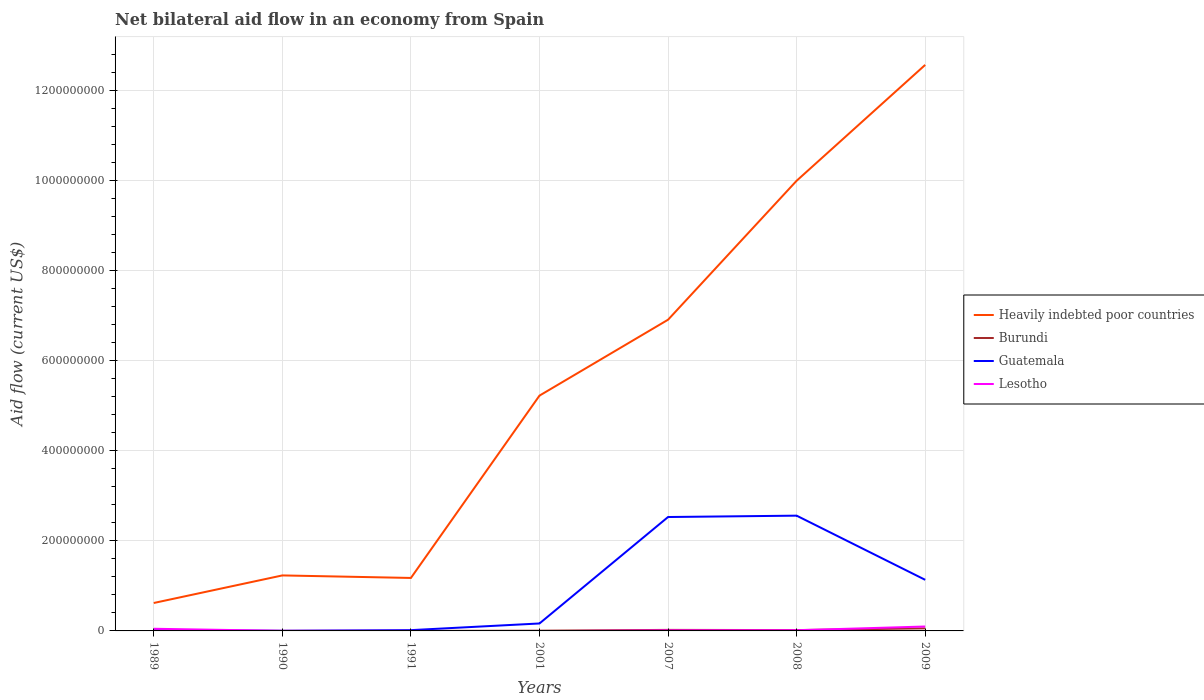Is the number of lines equal to the number of legend labels?
Offer a very short reply. No. Across all years, what is the maximum net bilateral aid flow in Guatemala?
Your response must be concise. 2.50e+05. What is the total net bilateral aid flow in Guatemala in the graph?
Offer a terse response. -1.50e+06. What is the difference between the highest and the second highest net bilateral aid flow in Lesotho?
Give a very brief answer. 9.77e+06. What is the difference between the highest and the lowest net bilateral aid flow in Lesotho?
Your answer should be compact. 2. How many years are there in the graph?
Your response must be concise. 7. Where does the legend appear in the graph?
Make the answer very short. Center right. What is the title of the graph?
Your response must be concise. Net bilateral aid flow in an economy from Spain. Does "Paraguay" appear as one of the legend labels in the graph?
Make the answer very short. No. What is the label or title of the Y-axis?
Make the answer very short. Aid flow (current US$). What is the Aid flow (current US$) in Heavily indebted poor countries in 1989?
Keep it short and to the point. 6.20e+07. What is the Aid flow (current US$) in Burundi in 1989?
Your response must be concise. 4.00e+04. What is the Aid flow (current US$) in Guatemala in 1989?
Ensure brevity in your answer.  1.59e+06. What is the Aid flow (current US$) of Lesotho in 1989?
Your answer should be compact. 4.79e+06. What is the Aid flow (current US$) in Heavily indebted poor countries in 1990?
Ensure brevity in your answer.  1.23e+08. What is the Aid flow (current US$) in Lesotho in 1990?
Ensure brevity in your answer.  1.50e+05. What is the Aid flow (current US$) of Heavily indebted poor countries in 1991?
Make the answer very short. 1.18e+08. What is the Aid flow (current US$) in Burundi in 1991?
Make the answer very short. 9.00e+04. What is the Aid flow (current US$) of Guatemala in 1991?
Provide a short and direct response. 1.75e+06. What is the Aid flow (current US$) of Lesotho in 1991?
Offer a very short reply. 5.00e+04. What is the Aid flow (current US$) in Heavily indebted poor countries in 2001?
Your answer should be very brief. 5.22e+08. What is the Aid flow (current US$) in Burundi in 2001?
Provide a short and direct response. 5.10e+05. What is the Aid flow (current US$) in Guatemala in 2001?
Offer a terse response. 1.65e+07. What is the Aid flow (current US$) of Heavily indebted poor countries in 2007?
Give a very brief answer. 6.91e+08. What is the Aid flow (current US$) of Burundi in 2007?
Your answer should be very brief. 2.29e+06. What is the Aid flow (current US$) in Guatemala in 2007?
Give a very brief answer. 2.53e+08. What is the Aid flow (current US$) in Lesotho in 2007?
Your answer should be compact. 1.18e+06. What is the Aid flow (current US$) in Heavily indebted poor countries in 2008?
Provide a short and direct response. 9.99e+08. What is the Aid flow (current US$) in Burundi in 2008?
Offer a terse response. 1.88e+06. What is the Aid flow (current US$) of Guatemala in 2008?
Offer a very short reply. 2.56e+08. What is the Aid flow (current US$) in Lesotho in 2008?
Keep it short and to the point. 1.53e+06. What is the Aid flow (current US$) of Heavily indebted poor countries in 2009?
Provide a succinct answer. 1.26e+09. What is the Aid flow (current US$) in Burundi in 2009?
Offer a terse response. 5.70e+06. What is the Aid flow (current US$) in Guatemala in 2009?
Make the answer very short. 1.13e+08. What is the Aid flow (current US$) in Lesotho in 2009?
Provide a succinct answer. 9.77e+06. Across all years, what is the maximum Aid flow (current US$) of Heavily indebted poor countries?
Your answer should be very brief. 1.26e+09. Across all years, what is the maximum Aid flow (current US$) of Burundi?
Ensure brevity in your answer.  5.70e+06. Across all years, what is the maximum Aid flow (current US$) of Guatemala?
Offer a terse response. 2.56e+08. Across all years, what is the maximum Aid flow (current US$) in Lesotho?
Make the answer very short. 9.77e+06. Across all years, what is the minimum Aid flow (current US$) in Heavily indebted poor countries?
Make the answer very short. 6.20e+07. Across all years, what is the minimum Aid flow (current US$) of Guatemala?
Make the answer very short. 2.50e+05. Across all years, what is the minimum Aid flow (current US$) of Lesotho?
Your answer should be compact. 0. What is the total Aid flow (current US$) of Heavily indebted poor countries in the graph?
Keep it short and to the point. 3.77e+09. What is the total Aid flow (current US$) of Burundi in the graph?
Provide a succinct answer. 1.06e+07. What is the total Aid flow (current US$) in Guatemala in the graph?
Ensure brevity in your answer.  6.42e+08. What is the total Aid flow (current US$) of Lesotho in the graph?
Make the answer very short. 1.75e+07. What is the difference between the Aid flow (current US$) of Heavily indebted poor countries in 1989 and that in 1990?
Ensure brevity in your answer.  -6.12e+07. What is the difference between the Aid flow (current US$) in Burundi in 1989 and that in 1990?
Make the answer very short. -5.00e+04. What is the difference between the Aid flow (current US$) in Guatemala in 1989 and that in 1990?
Offer a very short reply. 1.34e+06. What is the difference between the Aid flow (current US$) in Lesotho in 1989 and that in 1990?
Your answer should be compact. 4.64e+06. What is the difference between the Aid flow (current US$) in Heavily indebted poor countries in 1989 and that in 1991?
Your answer should be compact. -5.56e+07. What is the difference between the Aid flow (current US$) in Burundi in 1989 and that in 1991?
Provide a succinct answer. -5.00e+04. What is the difference between the Aid flow (current US$) of Guatemala in 1989 and that in 1991?
Provide a short and direct response. -1.60e+05. What is the difference between the Aid flow (current US$) in Lesotho in 1989 and that in 1991?
Offer a terse response. 4.74e+06. What is the difference between the Aid flow (current US$) of Heavily indebted poor countries in 1989 and that in 2001?
Ensure brevity in your answer.  -4.60e+08. What is the difference between the Aid flow (current US$) in Burundi in 1989 and that in 2001?
Offer a very short reply. -4.70e+05. What is the difference between the Aid flow (current US$) in Guatemala in 1989 and that in 2001?
Provide a short and direct response. -1.49e+07. What is the difference between the Aid flow (current US$) in Heavily indebted poor countries in 1989 and that in 2007?
Ensure brevity in your answer.  -6.29e+08. What is the difference between the Aid flow (current US$) of Burundi in 1989 and that in 2007?
Provide a succinct answer. -2.25e+06. What is the difference between the Aid flow (current US$) of Guatemala in 1989 and that in 2007?
Provide a succinct answer. -2.51e+08. What is the difference between the Aid flow (current US$) of Lesotho in 1989 and that in 2007?
Keep it short and to the point. 3.61e+06. What is the difference between the Aid flow (current US$) in Heavily indebted poor countries in 1989 and that in 2008?
Ensure brevity in your answer.  -9.37e+08. What is the difference between the Aid flow (current US$) in Burundi in 1989 and that in 2008?
Ensure brevity in your answer.  -1.84e+06. What is the difference between the Aid flow (current US$) of Guatemala in 1989 and that in 2008?
Ensure brevity in your answer.  -2.54e+08. What is the difference between the Aid flow (current US$) in Lesotho in 1989 and that in 2008?
Your response must be concise. 3.26e+06. What is the difference between the Aid flow (current US$) of Heavily indebted poor countries in 1989 and that in 2009?
Your answer should be very brief. -1.19e+09. What is the difference between the Aid flow (current US$) of Burundi in 1989 and that in 2009?
Give a very brief answer. -5.66e+06. What is the difference between the Aid flow (current US$) in Guatemala in 1989 and that in 2009?
Ensure brevity in your answer.  -1.12e+08. What is the difference between the Aid flow (current US$) of Lesotho in 1989 and that in 2009?
Provide a short and direct response. -4.98e+06. What is the difference between the Aid flow (current US$) of Heavily indebted poor countries in 1990 and that in 1991?
Offer a terse response. 5.61e+06. What is the difference between the Aid flow (current US$) in Burundi in 1990 and that in 1991?
Give a very brief answer. 0. What is the difference between the Aid flow (current US$) of Guatemala in 1990 and that in 1991?
Make the answer very short. -1.50e+06. What is the difference between the Aid flow (current US$) in Heavily indebted poor countries in 1990 and that in 2001?
Make the answer very short. -3.99e+08. What is the difference between the Aid flow (current US$) in Burundi in 1990 and that in 2001?
Give a very brief answer. -4.20e+05. What is the difference between the Aid flow (current US$) of Guatemala in 1990 and that in 2001?
Offer a terse response. -1.63e+07. What is the difference between the Aid flow (current US$) in Heavily indebted poor countries in 1990 and that in 2007?
Provide a succinct answer. -5.68e+08. What is the difference between the Aid flow (current US$) of Burundi in 1990 and that in 2007?
Give a very brief answer. -2.20e+06. What is the difference between the Aid flow (current US$) in Guatemala in 1990 and that in 2007?
Offer a terse response. -2.53e+08. What is the difference between the Aid flow (current US$) in Lesotho in 1990 and that in 2007?
Provide a short and direct response. -1.03e+06. What is the difference between the Aid flow (current US$) in Heavily indebted poor countries in 1990 and that in 2008?
Make the answer very short. -8.76e+08. What is the difference between the Aid flow (current US$) of Burundi in 1990 and that in 2008?
Keep it short and to the point. -1.79e+06. What is the difference between the Aid flow (current US$) of Guatemala in 1990 and that in 2008?
Offer a very short reply. -2.56e+08. What is the difference between the Aid flow (current US$) in Lesotho in 1990 and that in 2008?
Your answer should be compact. -1.38e+06. What is the difference between the Aid flow (current US$) of Heavily indebted poor countries in 1990 and that in 2009?
Provide a succinct answer. -1.13e+09. What is the difference between the Aid flow (current US$) in Burundi in 1990 and that in 2009?
Make the answer very short. -5.61e+06. What is the difference between the Aid flow (current US$) of Guatemala in 1990 and that in 2009?
Make the answer very short. -1.13e+08. What is the difference between the Aid flow (current US$) of Lesotho in 1990 and that in 2009?
Offer a terse response. -9.62e+06. What is the difference between the Aid flow (current US$) of Heavily indebted poor countries in 1991 and that in 2001?
Provide a succinct answer. -4.05e+08. What is the difference between the Aid flow (current US$) in Burundi in 1991 and that in 2001?
Make the answer very short. -4.20e+05. What is the difference between the Aid flow (current US$) in Guatemala in 1991 and that in 2001?
Give a very brief answer. -1.48e+07. What is the difference between the Aid flow (current US$) of Heavily indebted poor countries in 1991 and that in 2007?
Your answer should be very brief. -5.73e+08. What is the difference between the Aid flow (current US$) of Burundi in 1991 and that in 2007?
Ensure brevity in your answer.  -2.20e+06. What is the difference between the Aid flow (current US$) of Guatemala in 1991 and that in 2007?
Your response must be concise. -2.51e+08. What is the difference between the Aid flow (current US$) of Lesotho in 1991 and that in 2007?
Offer a very short reply. -1.13e+06. What is the difference between the Aid flow (current US$) of Heavily indebted poor countries in 1991 and that in 2008?
Ensure brevity in your answer.  -8.82e+08. What is the difference between the Aid flow (current US$) of Burundi in 1991 and that in 2008?
Your response must be concise. -1.79e+06. What is the difference between the Aid flow (current US$) of Guatemala in 1991 and that in 2008?
Keep it short and to the point. -2.54e+08. What is the difference between the Aid flow (current US$) in Lesotho in 1991 and that in 2008?
Give a very brief answer. -1.48e+06. What is the difference between the Aid flow (current US$) in Heavily indebted poor countries in 1991 and that in 2009?
Your response must be concise. -1.14e+09. What is the difference between the Aid flow (current US$) of Burundi in 1991 and that in 2009?
Give a very brief answer. -5.61e+06. What is the difference between the Aid flow (current US$) in Guatemala in 1991 and that in 2009?
Keep it short and to the point. -1.12e+08. What is the difference between the Aid flow (current US$) of Lesotho in 1991 and that in 2009?
Offer a terse response. -9.72e+06. What is the difference between the Aid flow (current US$) in Heavily indebted poor countries in 2001 and that in 2007?
Give a very brief answer. -1.69e+08. What is the difference between the Aid flow (current US$) of Burundi in 2001 and that in 2007?
Provide a succinct answer. -1.78e+06. What is the difference between the Aid flow (current US$) in Guatemala in 2001 and that in 2007?
Provide a succinct answer. -2.36e+08. What is the difference between the Aid flow (current US$) of Heavily indebted poor countries in 2001 and that in 2008?
Your answer should be very brief. -4.77e+08. What is the difference between the Aid flow (current US$) in Burundi in 2001 and that in 2008?
Give a very brief answer. -1.37e+06. What is the difference between the Aid flow (current US$) of Guatemala in 2001 and that in 2008?
Ensure brevity in your answer.  -2.39e+08. What is the difference between the Aid flow (current US$) in Heavily indebted poor countries in 2001 and that in 2009?
Your answer should be very brief. -7.34e+08. What is the difference between the Aid flow (current US$) of Burundi in 2001 and that in 2009?
Your response must be concise. -5.19e+06. What is the difference between the Aid flow (current US$) of Guatemala in 2001 and that in 2009?
Provide a succinct answer. -9.69e+07. What is the difference between the Aid flow (current US$) of Heavily indebted poor countries in 2007 and that in 2008?
Provide a short and direct response. -3.09e+08. What is the difference between the Aid flow (current US$) of Guatemala in 2007 and that in 2008?
Provide a succinct answer. -3.02e+06. What is the difference between the Aid flow (current US$) of Lesotho in 2007 and that in 2008?
Your answer should be compact. -3.50e+05. What is the difference between the Aid flow (current US$) in Heavily indebted poor countries in 2007 and that in 2009?
Offer a terse response. -5.66e+08. What is the difference between the Aid flow (current US$) of Burundi in 2007 and that in 2009?
Offer a very short reply. -3.41e+06. What is the difference between the Aid flow (current US$) in Guatemala in 2007 and that in 2009?
Offer a terse response. 1.39e+08. What is the difference between the Aid flow (current US$) of Lesotho in 2007 and that in 2009?
Keep it short and to the point. -8.59e+06. What is the difference between the Aid flow (current US$) of Heavily indebted poor countries in 2008 and that in 2009?
Offer a very short reply. -2.57e+08. What is the difference between the Aid flow (current US$) of Burundi in 2008 and that in 2009?
Provide a succinct answer. -3.82e+06. What is the difference between the Aid flow (current US$) of Guatemala in 2008 and that in 2009?
Offer a very short reply. 1.42e+08. What is the difference between the Aid flow (current US$) in Lesotho in 2008 and that in 2009?
Provide a short and direct response. -8.24e+06. What is the difference between the Aid flow (current US$) in Heavily indebted poor countries in 1989 and the Aid flow (current US$) in Burundi in 1990?
Offer a terse response. 6.19e+07. What is the difference between the Aid flow (current US$) in Heavily indebted poor countries in 1989 and the Aid flow (current US$) in Guatemala in 1990?
Your answer should be compact. 6.18e+07. What is the difference between the Aid flow (current US$) in Heavily indebted poor countries in 1989 and the Aid flow (current US$) in Lesotho in 1990?
Give a very brief answer. 6.18e+07. What is the difference between the Aid flow (current US$) in Burundi in 1989 and the Aid flow (current US$) in Lesotho in 1990?
Ensure brevity in your answer.  -1.10e+05. What is the difference between the Aid flow (current US$) of Guatemala in 1989 and the Aid flow (current US$) of Lesotho in 1990?
Offer a terse response. 1.44e+06. What is the difference between the Aid flow (current US$) of Heavily indebted poor countries in 1989 and the Aid flow (current US$) of Burundi in 1991?
Your answer should be very brief. 6.19e+07. What is the difference between the Aid flow (current US$) of Heavily indebted poor countries in 1989 and the Aid flow (current US$) of Guatemala in 1991?
Your answer should be compact. 6.02e+07. What is the difference between the Aid flow (current US$) of Heavily indebted poor countries in 1989 and the Aid flow (current US$) of Lesotho in 1991?
Your answer should be compact. 6.20e+07. What is the difference between the Aid flow (current US$) of Burundi in 1989 and the Aid flow (current US$) of Guatemala in 1991?
Give a very brief answer. -1.71e+06. What is the difference between the Aid flow (current US$) of Guatemala in 1989 and the Aid flow (current US$) of Lesotho in 1991?
Ensure brevity in your answer.  1.54e+06. What is the difference between the Aid flow (current US$) in Heavily indebted poor countries in 1989 and the Aid flow (current US$) in Burundi in 2001?
Keep it short and to the point. 6.15e+07. What is the difference between the Aid flow (current US$) of Heavily indebted poor countries in 1989 and the Aid flow (current US$) of Guatemala in 2001?
Give a very brief answer. 4.55e+07. What is the difference between the Aid flow (current US$) of Burundi in 1989 and the Aid flow (current US$) of Guatemala in 2001?
Offer a terse response. -1.65e+07. What is the difference between the Aid flow (current US$) in Heavily indebted poor countries in 1989 and the Aid flow (current US$) in Burundi in 2007?
Ensure brevity in your answer.  5.97e+07. What is the difference between the Aid flow (current US$) in Heavily indebted poor countries in 1989 and the Aid flow (current US$) in Guatemala in 2007?
Give a very brief answer. -1.91e+08. What is the difference between the Aid flow (current US$) in Heavily indebted poor countries in 1989 and the Aid flow (current US$) in Lesotho in 2007?
Make the answer very short. 6.08e+07. What is the difference between the Aid flow (current US$) of Burundi in 1989 and the Aid flow (current US$) of Guatemala in 2007?
Provide a succinct answer. -2.53e+08. What is the difference between the Aid flow (current US$) in Burundi in 1989 and the Aid flow (current US$) in Lesotho in 2007?
Give a very brief answer. -1.14e+06. What is the difference between the Aid flow (current US$) of Guatemala in 1989 and the Aid flow (current US$) of Lesotho in 2007?
Your answer should be compact. 4.10e+05. What is the difference between the Aid flow (current US$) of Heavily indebted poor countries in 1989 and the Aid flow (current US$) of Burundi in 2008?
Make the answer very short. 6.01e+07. What is the difference between the Aid flow (current US$) in Heavily indebted poor countries in 1989 and the Aid flow (current US$) in Guatemala in 2008?
Give a very brief answer. -1.94e+08. What is the difference between the Aid flow (current US$) in Heavily indebted poor countries in 1989 and the Aid flow (current US$) in Lesotho in 2008?
Offer a very short reply. 6.05e+07. What is the difference between the Aid flow (current US$) of Burundi in 1989 and the Aid flow (current US$) of Guatemala in 2008?
Your answer should be compact. -2.56e+08. What is the difference between the Aid flow (current US$) in Burundi in 1989 and the Aid flow (current US$) in Lesotho in 2008?
Offer a terse response. -1.49e+06. What is the difference between the Aid flow (current US$) of Guatemala in 1989 and the Aid flow (current US$) of Lesotho in 2008?
Ensure brevity in your answer.  6.00e+04. What is the difference between the Aid flow (current US$) of Heavily indebted poor countries in 1989 and the Aid flow (current US$) of Burundi in 2009?
Your response must be concise. 5.63e+07. What is the difference between the Aid flow (current US$) in Heavily indebted poor countries in 1989 and the Aid flow (current US$) in Guatemala in 2009?
Your response must be concise. -5.14e+07. What is the difference between the Aid flow (current US$) in Heavily indebted poor countries in 1989 and the Aid flow (current US$) in Lesotho in 2009?
Make the answer very short. 5.22e+07. What is the difference between the Aid flow (current US$) in Burundi in 1989 and the Aid flow (current US$) in Guatemala in 2009?
Keep it short and to the point. -1.13e+08. What is the difference between the Aid flow (current US$) of Burundi in 1989 and the Aid flow (current US$) of Lesotho in 2009?
Your response must be concise. -9.73e+06. What is the difference between the Aid flow (current US$) in Guatemala in 1989 and the Aid flow (current US$) in Lesotho in 2009?
Provide a short and direct response. -8.18e+06. What is the difference between the Aid flow (current US$) in Heavily indebted poor countries in 1990 and the Aid flow (current US$) in Burundi in 1991?
Offer a very short reply. 1.23e+08. What is the difference between the Aid flow (current US$) of Heavily indebted poor countries in 1990 and the Aid flow (current US$) of Guatemala in 1991?
Keep it short and to the point. 1.21e+08. What is the difference between the Aid flow (current US$) of Heavily indebted poor countries in 1990 and the Aid flow (current US$) of Lesotho in 1991?
Keep it short and to the point. 1.23e+08. What is the difference between the Aid flow (current US$) in Burundi in 1990 and the Aid flow (current US$) in Guatemala in 1991?
Offer a very short reply. -1.66e+06. What is the difference between the Aid flow (current US$) in Burundi in 1990 and the Aid flow (current US$) in Lesotho in 1991?
Ensure brevity in your answer.  4.00e+04. What is the difference between the Aid flow (current US$) of Heavily indebted poor countries in 1990 and the Aid flow (current US$) of Burundi in 2001?
Provide a short and direct response. 1.23e+08. What is the difference between the Aid flow (current US$) in Heavily indebted poor countries in 1990 and the Aid flow (current US$) in Guatemala in 2001?
Provide a succinct answer. 1.07e+08. What is the difference between the Aid flow (current US$) in Burundi in 1990 and the Aid flow (current US$) in Guatemala in 2001?
Your response must be concise. -1.64e+07. What is the difference between the Aid flow (current US$) of Heavily indebted poor countries in 1990 and the Aid flow (current US$) of Burundi in 2007?
Give a very brief answer. 1.21e+08. What is the difference between the Aid flow (current US$) of Heavily indebted poor countries in 1990 and the Aid flow (current US$) of Guatemala in 2007?
Provide a short and direct response. -1.30e+08. What is the difference between the Aid flow (current US$) of Heavily indebted poor countries in 1990 and the Aid flow (current US$) of Lesotho in 2007?
Provide a short and direct response. 1.22e+08. What is the difference between the Aid flow (current US$) in Burundi in 1990 and the Aid flow (current US$) in Guatemala in 2007?
Offer a terse response. -2.53e+08. What is the difference between the Aid flow (current US$) in Burundi in 1990 and the Aid flow (current US$) in Lesotho in 2007?
Give a very brief answer. -1.09e+06. What is the difference between the Aid flow (current US$) in Guatemala in 1990 and the Aid flow (current US$) in Lesotho in 2007?
Your answer should be compact. -9.30e+05. What is the difference between the Aid flow (current US$) of Heavily indebted poor countries in 1990 and the Aid flow (current US$) of Burundi in 2008?
Give a very brief answer. 1.21e+08. What is the difference between the Aid flow (current US$) of Heavily indebted poor countries in 1990 and the Aid flow (current US$) of Guatemala in 2008?
Offer a very short reply. -1.33e+08. What is the difference between the Aid flow (current US$) of Heavily indebted poor countries in 1990 and the Aid flow (current US$) of Lesotho in 2008?
Keep it short and to the point. 1.22e+08. What is the difference between the Aid flow (current US$) in Burundi in 1990 and the Aid flow (current US$) in Guatemala in 2008?
Provide a short and direct response. -2.56e+08. What is the difference between the Aid flow (current US$) in Burundi in 1990 and the Aid flow (current US$) in Lesotho in 2008?
Your answer should be very brief. -1.44e+06. What is the difference between the Aid flow (current US$) of Guatemala in 1990 and the Aid flow (current US$) of Lesotho in 2008?
Offer a terse response. -1.28e+06. What is the difference between the Aid flow (current US$) in Heavily indebted poor countries in 1990 and the Aid flow (current US$) in Burundi in 2009?
Provide a succinct answer. 1.17e+08. What is the difference between the Aid flow (current US$) of Heavily indebted poor countries in 1990 and the Aid flow (current US$) of Guatemala in 2009?
Give a very brief answer. 9.76e+06. What is the difference between the Aid flow (current US$) of Heavily indebted poor countries in 1990 and the Aid flow (current US$) of Lesotho in 2009?
Provide a succinct answer. 1.13e+08. What is the difference between the Aid flow (current US$) of Burundi in 1990 and the Aid flow (current US$) of Guatemala in 2009?
Your response must be concise. -1.13e+08. What is the difference between the Aid flow (current US$) of Burundi in 1990 and the Aid flow (current US$) of Lesotho in 2009?
Provide a short and direct response. -9.68e+06. What is the difference between the Aid flow (current US$) in Guatemala in 1990 and the Aid flow (current US$) in Lesotho in 2009?
Offer a very short reply. -9.52e+06. What is the difference between the Aid flow (current US$) of Heavily indebted poor countries in 1991 and the Aid flow (current US$) of Burundi in 2001?
Offer a terse response. 1.17e+08. What is the difference between the Aid flow (current US$) in Heavily indebted poor countries in 1991 and the Aid flow (current US$) in Guatemala in 2001?
Make the answer very short. 1.01e+08. What is the difference between the Aid flow (current US$) of Burundi in 1991 and the Aid flow (current US$) of Guatemala in 2001?
Offer a very short reply. -1.64e+07. What is the difference between the Aid flow (current US$) in Heavily indebted poor countries in 1991 and the Aid flow (current US$) in Burundi in 2007?
Make the answer very short. 1.15e+08. What is the difference between the Aid flow (current US$) of Heavily indebted poor countries in 1991 and the Aid flow (current US$) of Guatemala in 2007?
Give a very brief answer. -1.35e+08. What is the difference between the Aid flow (current US$) of Heavily indebted poor countries in 1991 and the Aid flow (current US$) of Lesotho in 2007?
Ensure brevity in your answer.  1.16e+08. What is the difference between the Aid flow (current US$) in Burundi in 1991 and the Aid flow (current US$) in Guatemala in 2007?
Give a very brief answer. -2.53e+08. What is the difference between the Aid flow (current US$) of Burundi in 1991 and the Aid flow (current US$) of Lesotho in 2007?
Ensure brevity in your answer.  -1.09e+06. What is the difference between the Aid flow (current US$) in Guatemala in 1991 and the Aid flow (current US$) in Lesotho in 2007?
Provide a short and direct response. 5.70e+05. What is the difference between the Aid flow (current US$) in Heavily indebted poor countries in 1991 and the Aid flow (current US$) in Burundi in 2008?
Offer a very short reply. 1.16e+08. What is the difference between the Aid flow (current US$) in Heavily indebted poor countries in 1991 and the Aid flow (current US$) in Guatemala in 2008?
Make the answer very short. -1.38e+08. What is the difference between the Aid flow (current US$) in Heavily indebted poor countries in 1991 and the Aid flow (current US$) in Lesotho in 2008?
Provide a short and direct response. 1.16e+08. What is the difference between the Aid flow (current US$) in Burundi in 1991 and the Aid flow (current US$) in Guatemala in 2008?
Ensure brevity in your answer.  -2.56e+08. What is the difference between the Aid flow (current US$) of Burundi in 1991 and the Aid flow (current US$) of Lesotho in 2008?
Offer a terse response. -1.44e+06. What is the difference between the Aid flow (current US$) of Guatemala in 1991 and the Aid flow (current US$) of Lesotho in 2008?
Offer a very short reply. 2.20e+05. What is the difference between the Aid flow (current US$) in Heavily indebted poor countries in 1991 and the Aid flow (current US$) in Burundi in 2009?
Ensure brevity in your answer.  1.12e+08. What is the difference between the Aid flow (current US$) of Heavily indebted poor countries in 1991 and the Aid flow (current US$) of Guatemala in 2009?
Make the answer very short. 4.15e+06. What is the difference between the Aid flow (current US$) in Heavily indebted poor countries in 1991 and the Aid flow (current US$) in Lesotho in 2009?
Your response must be concise. 1.08e+08. What is the difference between the Aid flow (current US$) in Burundi in 1991 and the Aid flow (current US$) in Guatemala in 2009?
Keep it short and to the point. -1.13e+08. What is the difference between the Aid flow (current US$) of Burundi in 1991 and the Aid flow (current US$) of Lesotho in 2009?
Give a very brief answer. -9.68e+06. What is the difference between the Aid flow (current US$) of Guatemala in 1991 and the Aid flow (current US$) of Lesotho in 2009?
Ensure brevity in your answer.  -8.02e+06. What is the difference between the Aid flow (current US$) of Heavily indebted poor countries in 2001 and the Aid flow (current US$) of Burundi in 2007?
Your response must be concise. 5.20e+08. What is the difference between the Aid flow (current US$) of Heavily indebted poor countries in 2001 and the Aid flow (current US$) of Guatemala in 2007?
Your answer should be compact. 2.69e+08. What is the difference between the Aid flow (current US$) of Heavily indebted poor countries in 2001 and the Aid flow (current US$) of Lesotho in 2007?
Offer a very short reply. 5.21e+08. What is the difference between the Aid flow (current US$) in Burundi in 2001 and the Aid flow (current US$) in Guatemala in 2007?
Your answer should be compact. -2.52e+08. What is the difference between the Aid flow (current US$) in Burundi in 2001 and the Aid flow (current US$) in Lesotho in 2007?
Your answer should be compact. -6.70e+05. What is the difference between the Aid flow (current US$) of Guatemala in 2001 and the Aid flow (current US$) of Lesotho in 2007?
Give a very brief answer. 1.54e+07. What is the difference between the Aid flow (current US$) of Heavily indebted poor countries in 2001 and the Aid flow (current US$) of Burundi in 2008?
Provide a succinct answer. 5.20e+08. What is the difference between the Aid flow (current US$) in Heavily indebted poor countries in 2001 and the Aid flow (current US$) in Guatemala in 2008?
Your answer should be compact. 2.66e+08. What is the difference between the Aid flow (current US$) of Heavily indebted poor countries in 2001 and the Aid flow (current US$) of Lesotho in 2008?
Your answer should be compact. 5.21e+08. What is the difference between the Aid flow (current US$) in Burundi in 2001 and the Aid flow (current US$) in Guatemala in 2008?
Give a very brief answer. -2.55e+08. What is the difference between the Aid flow (current US$) of Burundi in 2001 and the Aid flow (current US$) of Lesotho in 2008?
Your answer should be compact. -1.02e+06. What is the difference between the Aid flow (current US$) of Guatemala in 2001 and the Aid flow (current US$) of Lesotho in 2008?
Provide a succinct answer. 1.50e+07. What is the difference between the Aid flow (current US$) in Heavily indebted poor countries in 2001 and the Aid flow (current US$) in Burundi in 2009?
Make the answer very short. 5.17e+08. What is the difference between the Aid flow (current US$) in Heavily indebted poor countries in 2001 and the Aid flow (current US$) in Guatemala in 2009?
Make the answer very short. 4.09e+08. What is the difference between the Aid flow (current US$) in Heavily indebted poor countries in 2001 and the Aid flow (current US$) in Lesotho in 2009?
Make the answer very short. 5.13e+08. What is the difference between the Aid flow (current US$) of Burundi in 2001 and the Aid flow (current US$) of Guatemala in 2009?
Provide a succinct answer. -1.13e+08. What is the difference between the Aid flow (current US$) of Burundi in 2001 and the Aid flow (current US$) of Lesotho in 2009?
Give a very brief answer. -9.26e+06. What is the difference between the Aid flow (current US$) in Guatemala in 2001 and the Aid flow (current US$) in Lesotho in 2009?
Offer a terse response. 6.76e+06. What is the difference between the Aid flow (current US$) of Heavily indebted poor countries in 2007 and the Aid flow (current US$) of Burundi in 2008?
Ensure brevity in your answer.  6.89e+08. What is the difference between the Aid flow (current US$) of Heavily indebted poor countries in 2007 and the Aid flow (current US$) of Guatemala in 2008?
Ensure brevity in your answer.  4.35e+08. What is the difference between the Aid flow (current US$) of Heavily indebted poor countries in 2007 and the Aid flow (current US$) of Lesotho in 2008?
Your answer should be compact. 6.89e+08. What is the difference between the Aid flow (current US$) in Burundi in 2007 and the Aid flow (current US$) in Guatemala in 2008?
Offer a very short reply. -2.54e+08. What is the difference between the Aid flow (current US$) in Burundi in 2007 and the Aid flow (current US$) in Lesotho in 2008?
Ensure brevity in your answer.  7.60e+05. What is the difference between the Aid flow (current US$) of Guatemala in 2007 and the Aid flow (current US$) of Lesotho in 2008?
Keep it short and to the point. 2.51e+08. What is the difference between the Aid flow (current US$) in Heavily indebted poor countries in 2007 and the Aid flow (current US$) in Burundi in 2009?
Ensure brevity in your answer.  6.85e+08. What is the difference between the Aid flow (current US$) of Heavily indebted poor countries in 2007 and the Aid flow (current US$) of Guatemala in 2009?
Ensure brevity in your answer.  5.77e+08. What is the difference between the Aid flow (current US$) in Heavily indebted poor countries in 2007 and the Aid flow (current US$) in Lesotho in 2009?
Your answer should be compact. 6.81e+08. What is the difference between the Aid flow (current US$) of Burundi in 2007 and the Aid flow (current US$) of Guatemala in 2009?
Give a very brief answer. -1.11e+08. What is the difference between the Aid flow (current US$) of Burundi in 2007 and the Aid flow (current US$) of Lesotho in 2009?
Your answer should be very brief. -7.48e+06. What is the difference between the Aid flow (current US$) of Guatemala in 2007 and the Aid flow (current US$) of Lesotho in 2009?
Provide a succinct answer. 2.43e+08. What is the difference between the Aid flow (current US$) in Heavily indebted poor countries in 2008 and the Aid flow (current US$) in Burundi in 2009?
Provide a short and direct response. 9.94e+08. What is the difference between the Aid flow (current US$) of Heavily indebted poor countries in 2008 and the Aid flow (current US$) of Guatemala in 2009?
Your answer should be very brief. 8.86e+08. What is the difference between the Aid flow (current US$) of Heavily indebted poor countries in 2008 and the Aid flow (current US$) of Lesotho in 2009?
Your answer should be very brief. 9.90e+08. What is the difference between the Aid flow (current US$) of Burundi in 2008 and the Aid flow (current US$) of Guatemala in 2009?
Your answer should be very brief. -1.12e+08. What is the difference between the Aid flow (current US$) in Burundi in 2008 and the Aid flow (current US$) in Lesotho in 2009?
Offer a very short reply. -7.89e+06. What is the difference between the Aid flow (current US$) in Guatemala in 2008 and the Aid flow (current US$) in Lesotho in 2009?
Your response must be concise. 2.46e+08. What is the average Aid flow (current US$) of Heavily indebted poor countries per year?
Offer a very short reply. 5.39e+08. What is the average Aid flow (current US$) of Burundi per year?
Provide a succinct answer. 1.51e+06. What is the average Aid flow (current US$) of Guatemala per year?
Make the answer very short. 9.18e+07. What is the average Aid flow (current US$) in Lesotho per year?
Ensure brevity in your answer.  2.50e+06. In the year 1989, what is the difference between the Aid flow (current US$) in Heavily indebted poor countries and Aid flow (current US$) in Burundi?
Provide a short and direct response. 6.20e+07. In the year 1989, what is the difference between the Aid flow (current US$) of Heavily indebted poor countries and Aid flow (current US$) of Guatemala?
Ensure brevity in your answer.  6.04e+07. In the year 1989, what is the difference between the Aid flow (current US$) in Heavily indebted poor countries and Aid flow (current US$) in Lesotho?
Provide a short and direct response. 5.72e+07. In the year 1989, what is the difference between the Aid flow (current US$) of Burundi and Aid flow (current US$) of Guatemala?
Offer a terse response. -1.55e+06. In the year 1989, what is the difference between the Aid flow (current US$) of Burundi and Aid flow (current US$) of Lesotho?
Your answer should be compact. -4.75e+06. In the year 1989, what is the difference between the Aid flow (current US$) in Guatemala and Aid flow (current US$) in Lesotho?
Your response must be concise. -3.20e+06. In the year 1990, what is the difference between the Aid flow (current US$) in Heavily indebted poor countries and Aid flow (current US$) in Burundi?
Your answer should be very brief. 1.23e+08. In the year 1990, what is the difference between the Aid flow (current US$) in Heavily indebted poor countries and Aid flow (current US$) in Guatemala?
Keep it short and to the point. 1.23e+08. In the year 1990, what is the difference between the Aid flow (current US$) in Heavily indebted poor countries and Aid flow (current US$) in Lesotho?
Give a very brief answer. 1.23e+08. In the year 1990, what is the difference between the Aid flow (current US$) of Burundi and Aid flow (current US$) of Guatemala?
Provide a short and direct response. -1.60e+05. In the year 1990, what is the difference between the Aid flow (current US$) of Burundi and Aid flow (current US$) of Lesotho?
Give a very brief answer. -6.00e+04. In the year 1990, what is the difference between the Aid flow (current US$) of Guatemala and Aid flow (current US$) of Lesotho?
Offer a terse response. 1.00e+05. In the year 1991, what is the difference between the Aid flow (current US$) of Heavily indebted poor countries and Aid flow (current US$) of Burundi?
Give a very brief answer. 1.17e+08. In the year 1991, what is the difference between the Aid flow (current US$) of Heavily indebted poor countries and Aid flow (current US$) of Guatemala?
Your answer should be compact. 1.16e+08. In the year 1991, what is the difference between the Aid flow (current US$) in Heavily indebted poor countries and Aid flow (current US$) in Lesotho?
Make the answer very short. 1.18e+08. In the year 1991, what is the difference between the Aid flow (current US$) in Burundi and Aid flow (current US$) in Guatemala?
Offer a terse response. -1.66e+06. In the year 1991, what is the difference between the Aid flow (current US$) of Guatemala and Aid flow (current US$) of Lesotho?
Ensure brevity in your answer.  1.70e+06. In the year 2001, what is the difference between the Aid flow (current US$) in Heavily indebted poor countries and Aid flow (current US$) in Burundi?
Keep it short and to the point. 5.22e+08. In the year 2001, what is the difference between the Aid flow (current US$) of Heavily indebted poor countries and Aid flow (current US$) of Guatemala?
Offer a terse response. 5.06e+08. In the year 2001, what is the difference between the Aid flow (current US$) in Burundi and Aid flow (current US$) in Guatemala?
Your response must be concise. -1.60e+07. In the year 2007, what is the difference between the Aid flow (current US$) of Heavily indebted poor countries and Aid flow (current US$) of Burundi?
Your answer should be compact. 6.89e+08. In the year 2007, what is the difference between the Aid flow (current US$) of Heavily indebted poor countries and Aid flow (current US$) of Guatemala?
Your answer should be compact. 4.38e+08. In the year 2007, what is the difference between the Aid flow (current US$) of Heavily indebted poor countries and Aid flow (current US$) of Lesotho?
Your answer should be very brief. 6.90e+08. In the year 2007, what is the difference between the Aid flow (current US$) in Burundi and Aid flow (current US$) in Guatemala?
Your response must be concise. -2.51e+08. In the year 2007, what is the difference between the Aid flow (current US$) in Burundi and Aid flow (current US$) in Lesotho?
Your answer should be very brief. 1.11e+06. In the year 2007, what is the difference between the Aid flow (current US$) in Guatemala and Aid flow (current US$) in Lesotho?
Your answer should be compact. 2.52e+08. In the year 2008, what is the difference between the Aid flow (current US$) of Heavily indebted poor countries and Aid flow (current US$) of Burundi?
Ensure brevity in your answer.  9.98e+08. In the year 2008, what is the difference between the Aid flow (current US$) of Heavily indebted poor countries and Aid flow (current US$) of Guatemala?
Ensure brevity in your answer.  7.44e+08. In the year 2008, what is the difference between the Aid flow (current US$) in Heavily indebted poor countries and Aid flow (current US$) in Lesotho?
Give a very brief answer. 9.98e+08. In the year 2008, what is the difference between the Aid flow (current US$) in Burundi and Aid flow (current US$) in Guatemala?
Your response must be concise. -2.54e+08. In the year 2008, what is the difference between the Aid flow (current US$) of Burundi and Aid flow (current US$) of Lesotho?
Offer a terse response. 3.50e+05. In the year 2008, what is the difference between the Aid flow (current US$) in Guatemala and Aid flow (current US$) in Lesotho?
Your answer should be compact. 2.54e+08. In the year 2009, what is the difference between the Aid flow (current US$) of Heavily indebted poor countries and Aid flow (current US$) of Burundi?
Ensure brevity in your answer.  1.25e+09. In the year 2009, what is the difference between the Aid flow (current US$) of Heavily indebted poor countries and Aid flow (current US$) of Guatemala?
Make the answer very short. 1.14e+09. In the year 2009, what is the difference between the Aid flow (current US$) in Heavily indebted poor countries and Aid flow (current US$) in Lesotho?
Your answer should be very brief. 1.25e+09. In the year 2009, what is the difference between the Aid flow (current US$) in Burundi and Aid flow (current US$) in Guatemala?
Your answer should be compact. -1.08e+08. In the year 2009, what is the difference between the Aid flow (current US$) in Burundi and Aid flow (current US$) in Lesotho?
Offer a terse response. -4.07e+06. In the year 2009, what is the difference between the Aid flow (current US$) of Guatemala and Aid flow (current US$) of Lesotho?
Provide a succinct answer. 1.04e+08. What is the ratio of the Aid flow (current US$) of Heavily indebted poor countries in 1989 to that in 1990?
Make the answer very short. 0.5. What is the ratio of the Aid flow (current US$) of Burundi in 1989 to that in 1990?
Make the answer very short. 0.44. What is the ratio of the Aid flow (current US$) of Guatemala in 1989 to that in 1990?
Provide a succinct answer. 6.36. What is the ratio of the Aid flow (current US$) of Lesotho in 1989 to that in 1990?
Offer a terse response. 31.93. What is the ratio of the Aid flow (current US$) in Heavily indebted poor countries in 1989 to that in 1991?
Your response must be concise. 0.53. What is the ratio of the Aid flow (current US$) in Burundi in 1989 to that in 1991?
Your response must be concise. 0.44. What is the ratio of the Aid flow (current US$) of Guatemala in 1989 to that in 1991?
Your answer should be very brief. 0.91. What is the ratio of the Aid flow (current US$) of Lesotho in 1989 to that in 1991?
Offer a terse response. 95.8. What is the ratio of the Aid flow (current US$) in Heavily indebted poor countries in 1989 to that in 2001?
Provide a succinct answer. 0.12. What is the ratio of the Aid flow (current US$) in Burundi in 1989 to that in 2001?
Provide a short and direct response. 0.08. What is the ratio of the Aid flow (current US$) in Guatemala in 1989 to that in 2001?
Give a very brief answer. 0.1. What is the ratio of the Aid flow (current US$) of Heavily indebted poor countries in 1989 to that in 2007?
Ensure brevity in your answer.  0.09. What is the ratio of the Aid flow (current US$) in Burundi in 1989 to that in 2007?
Provide a succinct answer. 0.02. What is the ratio of the Aid flow (current US$) of Guatemala in 1989 to that in 2007?
Keep it short and to the point. 0.01. What is the ratio of the Aid flow (current US$) in Lesotho in 1989 to that in 2007?
Ensure brevity in your answer.  4.06. What is the ratio of the Aid flow (current US$) of Heavily indebted poor countries in 1989 to that in 2008?
Your answer should be compact. 0.06. What is the ratio of the Aid flow (current US$) in Burundi in 1989 to that in 2008?
Give a very brief answer. 0.02. What is the ratio of the Aid flow (current US$) in Guatemala in 1989 to that in 2008?
Make the answer very short. 0.01. What is the ratio of the Aid flow (current US$) of Lesotho in 1989 to that in 2008?
Your response must be concise. 3.13. What is the ratio of the Aid flow (current US$) in Heavily indebted poor countries in 1989 to that in 2009?
Ensure brevity in your answer.  0.05. What is the ratio of the Aid flow (current US$) in Burundi in 1989 to that in 2009?
Offer a very short reply. 0.01. What is the ratio of the Aid flow (current US$) of Guatemala in 1989 to that in 2009?
Your response must be concise. 0.01. What is the ratio of the Aid flow (current US$) in Lesotho in 1989 to that in 2009?
Ensure brevity in your answer.  0.49. What is the ratio of the Aid flow (current US$) of Heavily indebted poor countries in 1990 to that in 1991?
Your answer should be very brief. 1.05. What is the ratio of the Aid flow (current US$) in Guatemala in 1990 to that in 1991?
Make the answer very short. 0.14. What is the ratio of the Aid flow (current US$) in Heavily indebted poor countries in 1990 to that in 2001?
Provide a succinct answer. 0.24. What is the ratio of the Aid flow (current US$) of Burundi in 1990 to that in 2001?
Your answer should be compact. 0.18. What is the ratio of the Aid flow (current US$) in Guatemala in 1990 to that in 2001?
Your answer should be compact. 0.02. What is the ratio of the Aid flow (current US$) in Heavily indebted poor countries in 1990 to that in 2007?
Ensure brevity in your answer.  0.18. What is the ratio of the Aid flow (current US$) in Burundi in 1990 to that in 2007?
Give a very brief answer. 0.04. What is the ratio of the Aid flow (current US$) of Guatemala in 1990 to that in 2007?
Keep it short and to the point. 0. What is the ratio of the Aid flow (current US$) of Lesotho in 1990 to that in 2007?
Make the answer very short. 0.13. What is the ratio of the Aid flow (current US$) of Heavily indebted poor countries in 1990 to that in 2008?
Your answer should be very brief. 0.12. What is the ratio of the Aid flow (current US$) of Burundi in 1990 to that in 2008?
Ensure brevity in your answer.  0.05. What is the ratio of the Aid flow (current US$) of Lesotho in 1990 to that in 2008?
Your response must be concise. 0.1. What is the ratio of the Aid flow (current US$) in Heavily indebted poor countries in 1990 to that in 2009?
Give a very brief answer. 0.1. What is the ratio of the Aid flow (current US$) in Burundi in 1990 to that in 2009?
Make the answer very short. 0.02. What is the ratio of the Aid flow (current US$) of Guatemala in 1990 to that in 2009?
Provide a short and direct response. 0. What is the ratio of the Aid flow (current US$) of Lesotho in 1990 to that in 2009?
Your answer should be very brief. 0.02. What is the ratio of the Aid flow (current US$) of Heavily indebted poor countries in 1991 to that in 2001?
Offer a very short reply. 0.23. What is the ratio of the Aid flow (current US$) of Burundi in 1991 to that in 2001?
Make the answer very short. 0.18. What is the ratio of the Aid flow (current US$) in Guatemala in 1991 to that in 2001?
Offer a terse response. 0.11. What is the ratio of the Aid flow (current US$) of Heavily indebted poor countries in 1991 to that in 2007?
Offer a very short reply. 0.17. What is the ratio of the Aid flow (current US$) in Burundi in 1991 to that in 2007?
Your response must be concise. 0.04. What is the ratio of the Aid flow (current US$) of Guatemala in 1991 to that in 2007?
Make the answer very short. 0.01. What is the ratio of the Aid flow (current US$) in Lesotho in 1991 to that in 2007?
Provide a succinct answer. 0.04. What is the ratio of the Aid flow (current US$) in Heavily indebted poor countries in 1991 to that in 2008?
Offer a very short reply. 0.12. What is the ratio of the Aid flow (current US$) of Burundi in 1991 to that in 2008?
Offer a terse response. 0.05. What is the ratio of the Aid flow (current US$) of Guatemala in 1991 to that in 2008?
Provide a succinct answer. 0.01. What is the ratio of the Aid flow (current US$) in Lesotho in 1991 to that in 2008?
Your response must be concise. 0.03. What is the ratio of the Aid flow (current US$) in Heavily indebted poor countries in 1991 to that in 2009?
Give a very brief answer. 0.09. What is the ratio of the Aid flow (current US$) in Burundi in 1991 to that in 2009?
Your response must be concise. 0.02. What is the ratio of the Aid flow (current US$) of Guatemala in 1991 to that in 2009?
Your response must be concise. 0.02. What is the ratio of the Aid flow (current US$) of Lesotho in 1991 to that in 2009?
Your answer should be compact. 0.01. What is the ratio of the Aid flow (current US$) of Heavily indebted poor countries in 2001 to that in 2007?
Provide a succinct answer. 0.76. What is the ratio of the Aid flow (current US$) of Burundi in 2001 to that in 2007?
Your answer should be very brief. 0.22. What is the ratio of the Aid flow (current US$) in Guatemala in 2001 to that in 2007?
Provide a short and direct response. 0.07. What is the ratio of the Aid flow (current US$) of Heavily indebted poor countries in 2001 to that in 2008?
Give a very brief answer. 0.52. What is the ratio of the Aid flow (current US$) in Burundi in 2001 to that in 2008?
Offer a terse response. 0.27. What is the ratio of the Aid flow (current US$) in Guatemala in 2001 to that in 2008?
Provide a succinct answer. 0.06. What is the ratio of the Aid flow (current US$) in Heavily indebted poor countries in 2001 to that in 2009?
Provide a short and direct response. 0.42. What is the ratio of the Aid flow (current US$) in Burundi in 2001 to that in 2009?
Make the answer very short. 0.09. What is the ratio of the Aid flow (current US$) in Guatemala in 2001 to that in 2009?
Make the answer very short. 0.15. What is the ratio of the Aid flow (current US$) in Heavily indebted poor countries in 2007 to that in 2008?
Give a very brief answer. 0.69. What is the ratio of the Aid flow (current US$) of Burundi in 2007 to that in 2008?
Offer a terse response. 1.22. What is the ratio of the Aid flow (current US$) in Guatemala in 2007 to that in 2008?
Ensure brevity in your answer.  0.99. What is the ratio of the Aid flow (current US$) in Lesotho in 2007 to that in 2008?
Your response must be concise. 0.77. What is the ratio of the Aid flow (current US$) in Heavily indebted poor countries in 2007 to that in 2009?
Give a very brief answer. 0.55. What is the ratio of the Aid flow (current US$) in Burundi in 2007 to that in 2009?
Your response must be concise. 0.4. What is the ratio of the Aid flow (current US$) of Guatemala in 2007 to that in 2009?
Offer a terse response. 2.23. What is the ratio of the Aid flow (current US$) of Lesotho in 2007 to that in 2009?
Provide a short and direct response. 0.12. What is the ratio of the Aid flow (current US$) of Heavily indebted poor countries in 2008 to that in 2009?
Provide a short and direct response. 0.8. What is the ratio of the Aid flow (current US$) of Burundi in 2008 to that in 2009?
Your answer should be compact. 0.33. What is the ratio of the Aid flow (current US$) of Guatemala in 2008 to that in 2009?
Your response must be concise. 2.26. What is the ratio of the Aid flow (current US$) of Lesotho in 2008 to that in 2009?
Your response must be concise. 0.16. What is the difference between the highest and the second highest Aid flow (current US$) of Heavily indebted poor countries?
Make the answer very short. 2.57e+08. What is the difference between the highest and the second highest Aid flow (current US$) of Burundi?
Provide a succinct answer. 3.41e+06. What is the difference between the highest and the second highest Aid flow (current US$) of Guatemala?
Offer a very short reply. 3.02e+06. What is the difference between the highest and the second highest Aid flow (current US$) of Lesotho?
Your answer should be compact. 4.98e+06. What is the difference between the highest and the lowest Aid flow (current US$) in Heavily indebted poor countries?
Give a very brief answer. 1.19e+09. What is the difference between the highest and the lowest Aid flow (current US$) in Burundi?
Give a very brief answer. 5.66e+06. What is the difference between the highest and the lowest Aid flow (current US$) in Guatemala?
Give a very brief answer. 2.56e+08. What is the difference between the highest and the lowest Aid flow (current US$) of Lesotho?
Make the answer very short. 9.77e+06. 